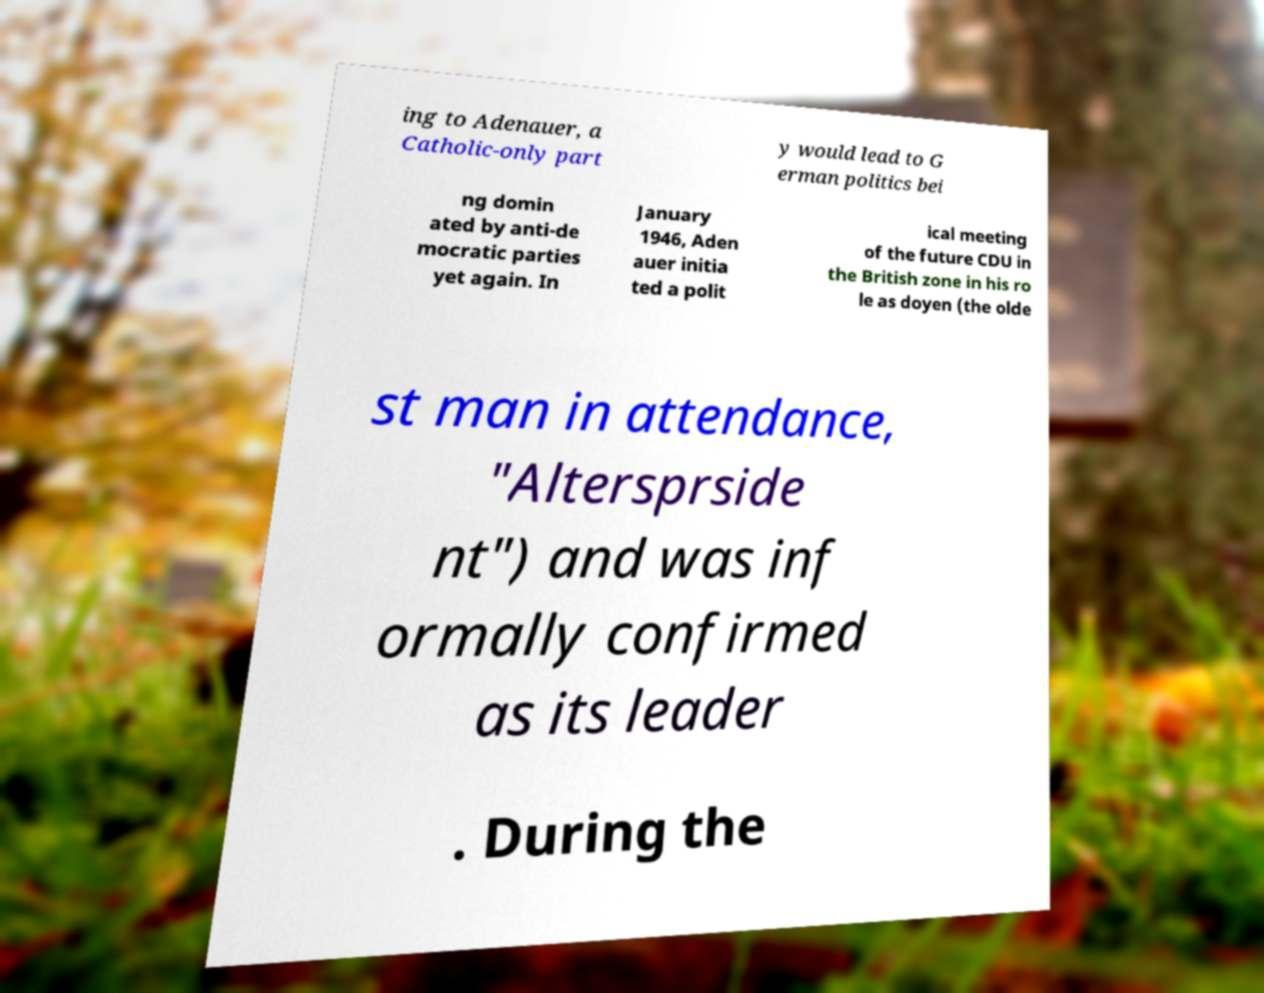What messages or text are displayed in this image? I need them in a readable, typed format. ing to Adenauer, a Catholic-only part y would lead to G erman politics bei ng domin ated by anti-de mocratic parties yet again. In January 1946, Aden auer initia ted a polit ical meeting of the future CDU in the British zone in his ro le as doyen (the olde st man in attendance, "Altersprside nt") and was inf ormally confirmed as its leader . During the 